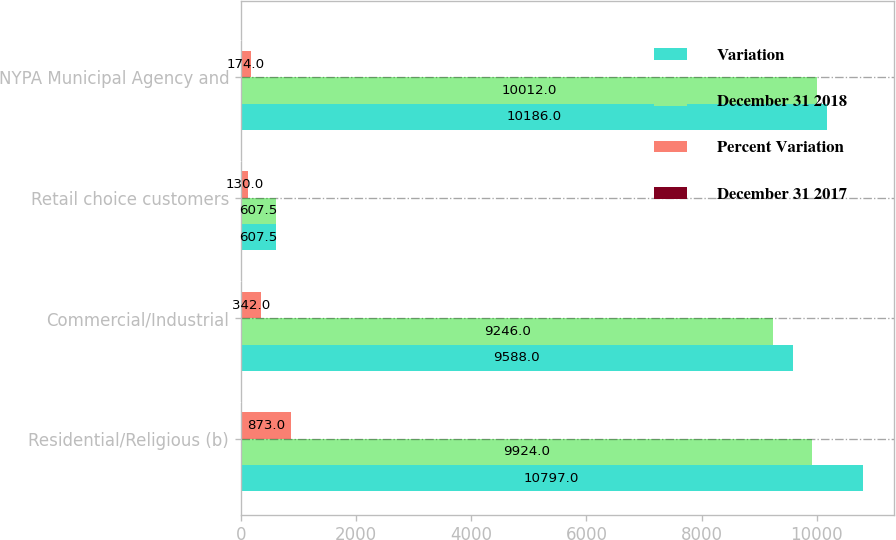Convert chart. <chart><loc_0><loc_0><loc_500><loc_500><stacked_bar_chart><ecel><fcel>Residential/Religious (b)<fcel>Commercial/Industrial<fcel>Retail choice customers<fcel>NYPA Municipal Agency and<nl><fcel>Variation<fcel>10797<fcel>9588<fcel>607.5<fcel>10186<nl><fcel>December 31 2018<fcel>9924<fcel>9246<fcel>607.5<fcel>10012<nl><fcel>Percent Variation<fcel>873<fcel>342<fcel>130<fcel>174<nl><fcel>December 31 2017<fcel>8.8<fcel>3.7<fcel>0.5<fcel>1.7<nl></chart> 